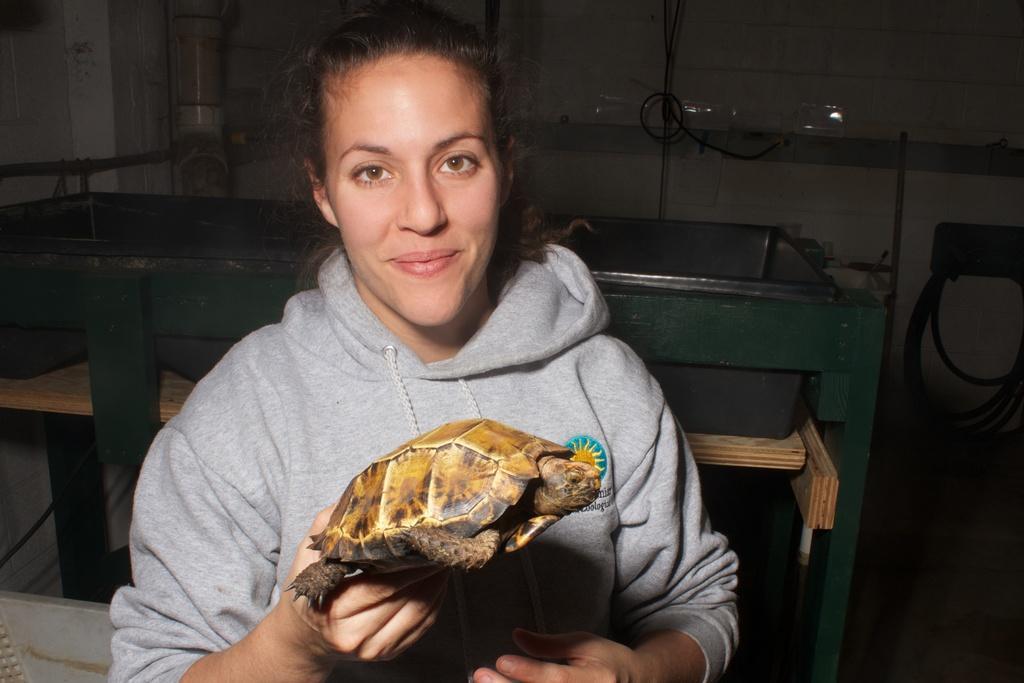In one or two sentences, can you explain what this image depicts? In this picture we can see a woman and she is holding a tortoise and in the background we can see a wall, pipe and some objects. 